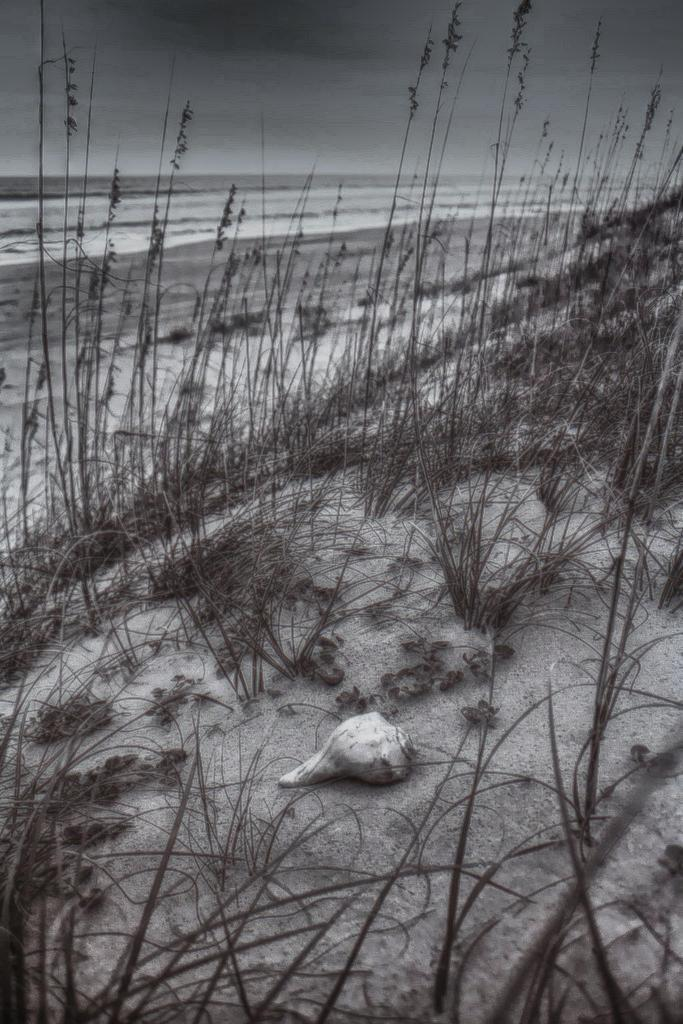What is located at the bottom of the image? There is a shell, sand, and plants at the bottom of the image. What type of environment is depicted at the bottom of the image? The environment at the bottom of the image includes a shell, sand, and plants, which suggests a beach setting. What can be seen in the background of the image? There is a beach visible in the background of the image. What type of yard is visible in the image? There is no yard present in the image; it depicts a beach setting with a shell, sand, plants, and a beach visible in the background. 